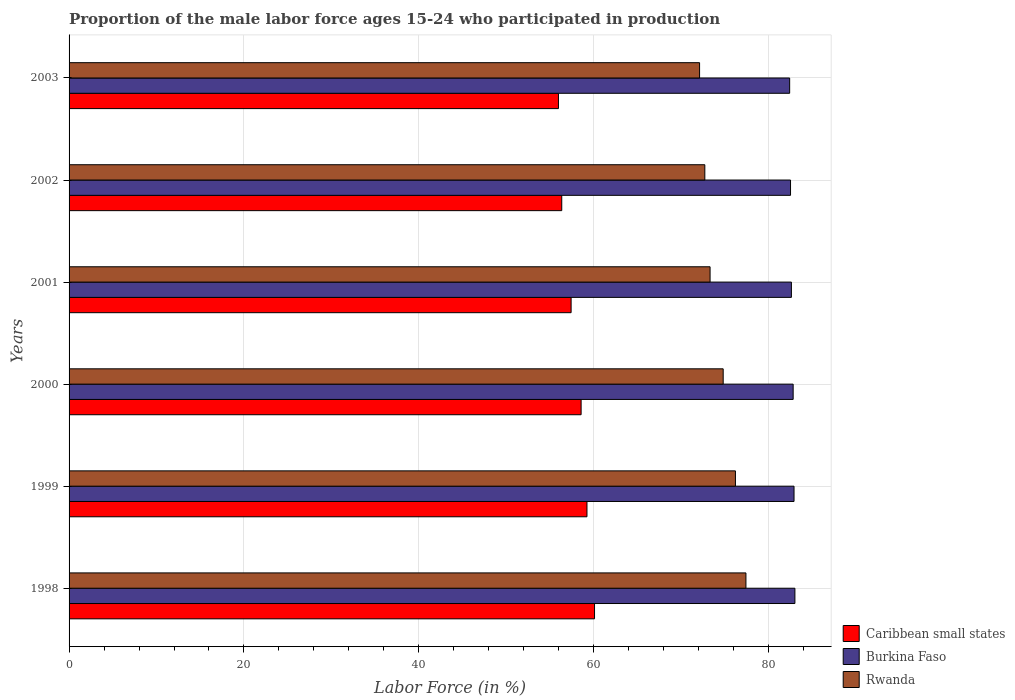How many different coloured bars are there?
Provide a short and direct response. 3. Are the number of bars on each tick of the Y-axis equal?
Ensure brevity in your answer.  Yes. How many bars are there on the 5th tick from the bottom?
Keep it short and to the point. 3. In how many cases, is the number of bars for a given year not equal to the number of legend labels?
Offer a very short reply. 0. What is the proportion of the male labor force who participated in production in Caribbean small states in 2000?
Your answer should be compact. 58.55. Across all years, what is the maximum proportion of the male labor force who participated in production in Burkina Faso?
Your answer should be very brief. 83. Across all years, what is the minimum proportion of the male labor force who participated in production in Caribbean small states?
Your answer should be very brief. 55.96. In which year was the proportion of the male labor force who participated in production in Caribbean small states minimum?
Give a very brief answer. 2003. What is the total proportion of the male labor force who participated in production in Burkina Faso in the graph?
Offer a very short reply. 496.2. What is the difference between the proportion of the male labor force who participated in production in Caribbean small states in 1998 and that in 2000?
Make the answer very short. 1.53. What is the difference between the proportion of the male labor force who participated in production in Caribbean small states in 1998 and the proportion of the male labor force who participated in production in Burkina Faso in 2001?
Provide a succinct answer. -22.51. What is the average proportion of the male labor force who participated in production in Rwanda per year?
Your response must be concise. 74.42. In the year 2000, what is the difference between the proportion of the male labor force who participated in production in Burkina Faso and proportion of the male labor force who participated in production in Rwanda?
Provide a short and direct response. 8. What is the ratio of the proportion of the male labor force who participated in production in Caribbean small states in 1999 to that in 2001?
Your response must be concise. 1.03. Is the proportion of the male labor force who participated in production in Burkina Faso in 1998 less than that in 2000?
Your answer should be very brief. No. What is the difference between the highest and the second highest proportion of the male labor force who participated in production in Caribbean small states?
Keep it short and to the point. 0.87. What is the difference between the highest and the lowest proportion of the male labor force who participated in production in Burkina Faso?
Provide a short and direct response. 0.6. Is the sum of the proportion of the male labor force who participated in production in Rwanda in 2002 and 2003 greater than the maximum proportion of the male labor force who participated in production in Burkina Faso across all years?
Your answer should be very brief. Yes. What does the 2nd bar from the top in 2001 represents?
Ensure brevity in your answer.  Burkina Faso. What does the 2nd bar from the bottom in 2000 represents?
Provide a succinct answer. Burkina Faso. Is it the case that in every year, the sum of the proportion of the male labor force who participated in production in Burkina Faso and proportion of the male labor force who participated in production in Rwanda is greater than the proportion of the male labor force who participated in production in Caribbean small states?
Your answer should be very brief. Yes. How many bars are there?
Your answer should be very brief. 18. How many years are there in the graph?
Your response must be concise. 6. What is the difference between two consecutive major ticks on the X-axis?
Offer a terse response. 20. Are the values on the major ticks of X-axis written in scientific E-notation?
Provide a succinct answer. No. Does the graph contain any zero values?
Ensure brevity in your answer.  No. Does the graph contain grids?
Your answer should be compact. Yes. Where does the legend appear in the graph?
Keep it short and to the point. Bottom right. How many legend labels are there?
Give a very brief answer. 3. How are the legend labels stacked?
Offer a terse response. Vertical. What is the title of the graph?
Provide a short and direct response. Proportion of the male labor force ages 15-24 who participated in production. Does "Tanzania" appear as one of the legend labels in the graph?
Your answer should be very brief. No. What is the label or title of the X-axis?
Your answer should be compact. Labor Force (in %). What is the label or title of the Y-axis?
Keep it short and to the point. Years. What is the Labor Force (in %) in Caribbean small states in 1998?
Offer a very short reply. 60.09. What is the Labor Force (in %) of Burkina Faso in 1998?
Ensure brevity in your answer.  83. What is the Labor Force (in %) of Rwanda in 1998?
Provide a succinct answer. 77.4. What is the Labor Force (in %) in Caribbean small states in 1999?
Offer a terse response. 59.22. What is the Labor Force (in %) of Burkina Faso in 1999?
Make the answer very short. 82.9. What is the Labor Force (in %) of Rwanda in 1999?
Offer a very short reply. 76.2. What is the Labor Force (in %) of Caribbean small states in 2000?
Your answer should be very brief. 58.55. What is the Labor Force (in %) of Burkina Faso in 2000?
Give a very brief answer. 82.8. What is the Labor Force (in %) of Rwanda in 2000?
Offer a very short reply. 74.8. What is the Labor Force (in %) in Caribbean small states in 2001?
Your answer should be compact. 57.41. What is the Labor Force (in %) in Burkina Faso in 2001?
Ensure brevity in your answer.  82.6. What is the Labor Force (in %) of Rwanda in 2001?
Your answer should be compact. 73.3. What is the Labor Force (in %) of Caribbean small states in 2002?
Give a very brief answer. 56.34. What is the Labor Force (in %) in Burkina Faso in 2002?
Provide a succinct answer. 82.5. What is the Labor Force (in %) of Rwanda in 2002?
Your answer should be compact. 72.7. What is the Labor Force (in %) of Caribbean small states in 2003?
Make the answer very short. 55.96. What is the Labor Force (in %) in Burkina Faso in 2003?
Offer a terse response. 82.4. What is the Labor Force (in %) of Rwanda in 2003?
Your response must be concise. 72.1. Across all years, what is the maximum Labor Force (in %) of Caribbean small states?
Make the answer very short. 60.09. Across all years, what is the maximum Labor Force (in %) of Burkina Faso?
Offer a very short reply. 83. Across all years, what is the maximum Labor Force (in %) in Rwanda?
Your response must be concise. 77.4. Across all years, what is the minimum Labor Force (in %) in Caribbean small states?
Offer a very short reply. 55.96. Across all years, what is the minimum Labor Force (in %) of Burkina Faso?
Provide a short and direct response. 82.4. Across all years, what is the minimum Labor Force (in %) in Rwanda?
Offer a very short reply. 72.1. What is the total Labor Force (in %) of Caribbean small states in the graph?
Offer a very short reply. 347.57. What is the total Labor Force (in %) in Burkina Faso in the graph?
Offer a very short reply. 496.2. What is the total Labor Force (in %) of Rwanda in the graph?
Offer a terse response. 446.5. What is the difference between the Labor Force (in %) of Caribbean small states in 1998 and that in 1999?
Ensure brevity in your answer.  0.87. What is the difference between the Labor Force (in %) of Burkina Faso in 1998 and that in 1999?
Make the answer very short. 0.1. What is the difference between the Labor Force (in %) of Caribbean small states in 1998 and that in 2000?
Your answer should be very brief. 1.53. What is the difference between the Labor Force (in %) of Caribbean small states in 1998 and that in 2001?
Offer a very short reply. 2.68. What is the difference between the Labor Force (in %) of Burkina Faso in 1998 and that in 2001?
Offer a very short reply. 0.4. What is the difference between the Labor Force (in %) in Rwanda in 1998 and that in 2001?
Ensure brevity in your answer.  4.1. What is the difference between the Labor Force (in %) in Caribbean small states in 1998 and that in 2002?
Offer a terse response. 3.75. What is the difference between the Labor Force (in %) of Burkina Faso in 1998 and that in 2002?
Offer a very short reply. 0.5. What is the difference between the Labor Force (in %) of Rwanda in 1998 and that in 2002?
Keep it short and to the point. 4.7. What is the difference between the Labor Force (in %) in Caribbean small states in 1998 and that in 2003?
Your answer should be very brief. 4.13. What is the difference between the Labor Force (in %) in Burkina Faso in 1998 and that in 2003?
Your answer should be compact. 0.6. What is the difference between the Labor Force (in %) of Rwanda in 1998 and that in 2003?
Ensure brevity in your answer.  5.3. What is the difference between the Labor Force (in %) in Caribbean small states in 1999 and that in 2000?
Give a very brief answer. 0.67. What is the difference between the Labor Force (in %) of Rwanda in 1999 and that in 2000?
Offer a very short reply. 1.4. What is the difference between the Labor Force (in %) in Caribbean small states in 1999 and that in 2001?
Your answer should be very brief. 1.81. What is the difference between the Labor Force (in %) in Caribbean small states in 1999 and that in 2002?
Your answer should be very brief. 2.88. What is the difference between the Labor Force (in %) of Rwanda in 1999 and that in 2002?
Keep it short and to the point. 3.5. What is the difference between the Labor Force (in %) of Caribbean small states in 1999 and that in 2003?
Ensure brevity in your answer.  3.26. What is the difference between the Labor Force (in %) in Rwanda in 1999 and that in 2003?
Make the answer very short. 4.1. What is the difference between the Labor Force (in %) in Caribbean small states in 2000 and that in 2001?
Make the answer very short. 1.14. What is the difference between the Labor Force (in %) of Rwanda in 2000 and that in 2001?
Ensure brevity in your answer.  1.5. What is the difference between the Labor Force (in %) in Caribbean small states in 2000 and that in 2002?
Provide a succinct answer. 2.21. What is the difference between the Labor Force (in %) in Rwanda in 2000 and that in 2002?
Your answer should be very brief. 2.1. What is the difference between the Labor Force (in %) in Caribbean small states in 2000 and that in 2003?
Make the answer very short. 2.59. What is the difference between the Labor Force (in %) of Caribbean small states in 2001 and that in 2002?
Keep it short and to the point. 1.07. What is the difference between the Labor Force (in %) of Rwanda in 2001 and that in 2002?
Your answer should be very brief. 0.6. What is the difference between the Labor Force (in %) of Caribbean small states in 2001 and that in 2003?
Give a very brief answer. 1.45. What is the difference between the Labor Force (in %) of Burkina Faso in 2001 and that in 2003?
Give a very brief answer. 0.2. What is the difference between the Labor Force (in %) of Caribbean small states in 2002 and that in 2003?
Provide a succinct answer. 0.38. What is the difference between the Labor Force (in %) in Rwanda in 2002 and that in 2003?
Offer a very short reply. 0.6. What is the difference between the Labor Force (in %) in Caribbean small states in 1998 and the Labor Force (in %) in Burkina Faso in 1999?
Provide a succinct answer. -22.81. What is the difference between the Labor Force (in %) of Caribbean small states in 1998 and the Labor Force (in %) of Rwanda in 1999?
Your answer should be very brief. -16.11. What is the difference between the Labor Force (in %) of Caribbean small states in 1998 and the Labor Force (in %) of Burkina Faso in 2000?
Ensure brevity in your answer.  -22.71. What is the difference between the Labor Force (in %) in Caribbean small states in 1998 and the Labor Force (in %) in Rwanda in 2000?
Give a very brief answer. -14.71. What is the difference between the Labor Force (in %) in Burkina Faso in 1998 and the Labor Force (in %) in Rwanda in 2000?
Ensure brevity in your answer.  8.2. What is the difference between the Labor Force (in %) in Caribbean small states in 1998 and the Labor Force (in %) in Burkina Faso in 2001?
Ensure brevity in your answer.  -22.51. What is the difference between the Labor Force (in %) in Caribbean small states in 1998 and the Labor Force (in %) in Rwanda in 2001?
Provide a succinct answer. -13.21. What is the difference between the Labor Force (in %) of Burkina Faso in 1998 and the Labor Force (in %) of Rwanda in 2001?
Your answer should be very brief. 9.7. What is the difference between the Labor Force (in %) of Caribbean small states in 1998 and the Labor Force (in %) of Burkina Faso in 2002?
Your answer should be very brief. -22.41. What is the difference between the Labor Force (in %) in Caribbean small states in 1998 and the Labor Force (in %) in Rwanda in 2002?
Offer a very short reply. -12.61. What is the difference between the Labor Force (in %) of Caribbean small states in 1998 and the Labor Force (in %) of Burkina Faso in 2003?
Provide a short and direct response. -22.31. What is the difference between the Labor Force (in %) of Caribbean small states in 1998 and the Labor Force (in %) of Rwanda in 2003?
Give a very brief answer. -12.01. What is the difference between the Labor Force (in %) of Caribbean small states in 1999 and the Labor Force (in %) of Burkina Faso in 2000?
Offer a very short reply. -23.58. What is the difference between the Labor Force (in %) in Caribbean small states in 1999 and the Labor Force (in %) in Rwanda in 2000?
Provide a succinct answer. -15.58. What is the difference between the Labor Force (in %) of Burkina Faso in 1999 and the Labor Force (in %) of Rwanda in 2000?
Keep it short and to the point. 8.1. What is the difference between the Labor Force (in %) in Caribbean small states in 1999 and the Labor Force (in %) in Burkina Faso in 2001?
Offer a terse response. -23.38. What is the difference between the Labor Force (in %) of Caribbean small states in 1999 and the Labor Force (in %) of Rwanda in 2001?
Your answer should be very brief. -14.08. What is the difference between the Labor Force (in %) of Burkina Faso in 1999 and the Labor Force (in %) of Rwanda in 2001?
Ensure brevity in your answer.  9.6. What is the difference between the Labor Force (in %) of Caribbean small states in 1999 and the Labor Force (in %) of Burkina Faso in 2002?
Your answer should be compact. -23.28. What is the difference between the Labor Force (in %) in Caribbean small states in 1999 and the Labor Force (in %) in Rwanda in 2002?
Your answer should be compact. -13.48. What is the difference between the Labor Force (in %) of Caribbean small states in 1999 and the Labor Force (in %) of Burkina Faso in 2003?
Your answer should be very brief. -23.18. What is the difference between the Labor Force (in %) in Caribbean small states in 1999 and the Labor Force (in %) in Rwanda in 2003?
Offer a terse response. -12.88. What is the difference between the Labor Force (in %) in Burkina Faso in 1999 and the Labor Force (in %) in Rwanda in 2003?
Ensure brevity in your answer.  10.8. What is the difference between the Labor Force (in %) of Caribbean small states in 2000 and the Labor Force (in %) of Burkina Faso in 2001?
Your response must be concise. -24.05. What is the difference between the Labor Force (in %) in Caribbean small states in 2000 and the Labor Force (in %) in Rwanda in 2001?
Keep it short and to the point. -14.75. What is the difference between the Labor Force (in %) of Caribbean small states in 2000 and the Labor Force (in %) of Burkina Faso in 2002?
Keep it short and to the point. -23.95. What is the difference between the Labor Force (in %) in Caribbean small states in 2000 and the Labor Force (in %) in Rwanda in 2002?
Make the answer very short. -14.15. What is the difference between the Labor Force (in %) in Caribbean small states in 2000 and the Labor Force (in %) in Burkina Faso in 2003?
Your answer should be compact. -23.85. What is the difference between the Labor Force (in %) of Caribbean small states in 2000 and the Labor Force (in %) of Rwanda in 2003?
Make the answer very short. -13.55. What is the difference between the Labor Force (in %) in Caribbean small states in 2001 and the Labor Force (in %) in Burkina Faso in 2002?
Provide a succinct answer. -25.09. What is the difference between the Labor Force (in %) of Caribbean small states in 2001 and the Labor Force (in %) of Rwanda in 2002?
Provide a succinct answer. -15.29. What is the difference between the Labor Force (in %) in Burkina Faso in 2001 and the Labor Force (in %) in Rwanda in 2002?
Keep it short and to the point. 9.9. What is the difference between the Labor Force (in %) of Caribbean small states in 2001 and the Labor Force (in %) of Burkina Faso in 2003?
Provide a succinct answer. -24.99. What is the difference between the Labor Force (in %) of Caribbean small states in 2001 and the Labor Force (in %) of Rwanda in 2003?
Offer a terse response. -14.69. What is the difference between the Labor Force (in %) in Caribbean small states in 2002 and the Labor Force (in %) in Burkina Faso in 2003?
Provide a succinct answer. -26.06. What is the difference between the Labor Force (in %) in Caribbean small states in 2002 and the Labor Force (in %) in Rwanda in 2003?
Your response must be concise. -15.76. What is the difference between the Labor Force (in %) of Burkina Faso in 2002 and the Labor Force (in %) of Rwanda in 2003?
Your answer should be very brief. 10.4. What is the average Labor Force (in %) of Caribbean small states per year?
Keep it short and to the point. 57.93. What is the average Labor Force (in %) of Burkina Faso per year?
Your answer should be very brief. 82.7. What is the average Labor Force (in %) in Rwanda per year?
Your response must be concise. 74.42. In the year 1998, what is the difference between the Labor Force (in %) of Caribbean small states and Labor Force (in %) of Burkina Faso?
Provide a short and direct response. -22.91. In the year 1998, what is the difference between the Labor Force (in %) of Caribbean small states and Labor Force (in %) of Rwanda?
Your answer should be very brief. -17.31. In the year 1998, what is the difference between the Labor Force (in %) in Burkina Faso and Labor Force (in %) in Rwanda?
Offer a terse response. 5.6. In the year 1999, what is the difference between the Labor Force (in %) of Caribbean small states and Labor Force (in %) of Burkina Faso?
Provide a succinct answer. -23.68. In the year 1999, what is the difference between the Labor Force (in %) of Caribbean small states and Labor Force (in %) of Rwanda?
Your answer should be compact. -16.98. In the year 2000, what is the difference between the Labor Force (in %) of Caribbean small states and Labor Force (in %) of Burkina Faso?
Your response must be concise. -24.25. In the year 2000, what is the difference between the Labor Force (in %) of Caribbean small states and Labor Force (in %) of Rwanda?
Give a very brief answer. -16.25. In the year 2001, what is the difference between the Labor Force (in %) of Caribbean small states and Labor Force (in %) of Burkina Faso?
Your answer should be compact. -25.19. In the year 2001, what is the difference between the Labor Force (in %) of Caribbean small states and Labor Force (in %) of Rwanda?
Provide a succinct answer. -15.89. In the year 2002, what is the difference between the Labor Force (in %) of Caribbean small states and Labor Force (in %) of Burkina Faso?
Keep it short and to the point. -26.16. In the year 2002, what is the difference between the Labor Force (in %) in Caribbean small states and Labor Force (in %) in Rwanda?
Offer a terse response. -16.36. In the year 2002, what is the difference between the Labor Force (in %) in Burkina Faso and Labor Force (in %) in Rwanda?
Make the answer very short. 9.8. In the year 2003, what is the difference between the Labor Force (in %) of Caribbean small states and Labor Force (in %) of Burkina Faso?
Make the answer very short. -26.44. In the year 2003, what is the difference between the Labor Force (in %) of Caribbean small states and Labor Force (in %) of Rwanda?
Your answer should be compact. -16.14. What is the ratio of the Labor Force (in %) of Caribbean small states in 1998 to that in 1999?
Offer a terse response. 1.01. What is the ratio of the Labor Force (in %) of Rwanda in 1998 to that in 1999?
Ensure brevity in your answer.  1.02. What is the ratio of the Labor Force (in %) in Caribbean small states in 1998 to that in 2000?
Provide a short and direct response. 1.03. What is the ratio of the Labor Force (in %) of Rwanda in 1998 to that in 2000?
Provide a succinct answer. 1.03. What is the ratio of the Labor Force (in %) in Caribbean small states in 1998 to that in 2001?
Make the answer very short. 1.05. What is the ratio of the Labor Force (in %) in Rwanda in 1998 to that in 2001?
Offer a terse response. 1.06. What is the ratio of the Labor Force (in %) in Caribbean small states in 1998 to that in 2002?
Your answer should be compact. 1.07. What is the ratio of the Labor Force (in %) of Rwanda in 1998 to that in 2002?
Provide a succinct answer. 1.06. What is the ratio of the Labor Force (in %) in Caribbean small states in 1998 to that in 2003?
Your answer should be very brief. 1.07. What is the ratio of the Labor Force (in %) of Burkina Faso in 1998 to that in 2003?
Provide a short and direct response. 1.01. What is the ratio of the Labor Force (in %) of Rwanda in 1998 to that in 2003?
Keep it short and to the point. 1.07. What is the ratio of the Labor Force (in %) of Caribbean small states in 1999 to that in 2000?
Ensure brevity in your answer.  1.01. What is the ratio of the Labor Force (in %) of Burkina Faso in 1999 to that in 2000?
Give a very brief answer. 1. What is the ratio of the Labor Force (in %) in Rwanda in 1999 to that in 2000?
Your answer should be very brief. 1.02. What is the ratio of the Labor Force (in %) of Caribbean small states in 1999 to that in 2001?
Your answer should be compact. 1.03. What is the ratio of the Labor Force (in %) in Rwanda in 1999 to that in 2001?
Your answer should be compact. 1.04. What is the ratio of the Labor Force (in %) of Caribbean small states in 1999 to that in 2002?
Provide a short and direct response. 1.05. What is the ratio of the Labor Force (in %) in Rwanda in 1999 to that in 2002?
Provide a short and direct response. 1.05. What is the ratio of the Labor Force (in %) of Caribbean small states in 1999 to that in 2003?
Provide a succinct answer. 1.06. What is the ratio of the Labor Force (in %) of Burkina Faso in 1999 to that in 2003?
Offer a very short reply. 1.01. What is the ratio of the Labor Force (in %) in Rwanda in 1999 to that in 2003?
Make the answer very short. 1.06. What is the ratio of the Labor Force (in %) of Caribbean small states in 2000 to that in 2001?
Your answer should be very brief. 1.02. What is the ratio of the Labor Force (in %) in Burkina Faso in 2000 to that in 2001?
Offer a terse response. 1. What is the ratio of the Labor Force (in %) in Rwanda in 2000 to that in 2001?
Your response must be concise. 1.02. What is the ratio of the Labor Force (in %) in Caribbean small states in 2000 to that in 2002?
Make the answer very short. 1.04. What is the ratio of the Labor Force (in %) of Burkina Faso in 2000 to that in 2002?
Offer a terse response. 1. What is the ratio of the Labor Force (in %) of Rwanda in 2000 to that in 2002?
Your answer should be very brief. 1.03. What is the ratio of the Labor Force (in %) in Caribbean small states in 2000 to that in 2003?
Make the answer very short. 1.05. What is the ratio of the Labor Force (in %) in Rwanda in 2000 to that in 2003?
Provide a succinct answer. 1.04. What is the ratio of the Labor Force (in %) in Caribbean small states in 2001 to that in 2002?
Provide a short and direct response. 1.02. What is the ratio of the Labor Force (in %) in Burkina Faso in 2001 to that in 2002?
Offer a terse response. 1. What is the ratio of the Labor Force (in %) of Rwanda in 2001 to that in 2002?
Ensure brevity in your answer.  1.01. What is the ratio of the Labor Force (in %) in Caribbean small states in 2001 to that in 2003?
Keep it short and to the point. 1.03. What is the ratio of the Labor Force (in %) in Burkina Faso in 2001 to that in 2003?
Your response must be concise. 1. What is the ratio of the Labor Force (in %) in Rwanda in 2001 to that in 2003?
Offer a terse response. 1.02. What is the ratio of the Labor Force (in %) of Caribbean small states in 2002 to that in 2003?
Give a very brief answer. 1.01. What is the ratio of the Labor Force (in %) of Rwanda in 2002 to that in 2003?
Your response must be concise. 1.01. What is the difference between the highest and the second highest Labor Force (in %) in Caribbean small states?
Your answer should be very brief. 0.87. What is the difference between the highest and the second highest Labor Force (in %) of Burkina Faso?
Offer a terse response. 0.1. What is the difference between the highest and the second highest Labor Force (in %) of Rwanda?
Make the answer very short. 1.2. What is the difference between the highest and the lowest Labor Force (in %) of Caribbean small states?
Ensure brevity in your answer.  4.13. What is the difference between the highest and the lowest Labor Force (in %) in Burkina Faso?
Keep it short and to the point. 0.6. 